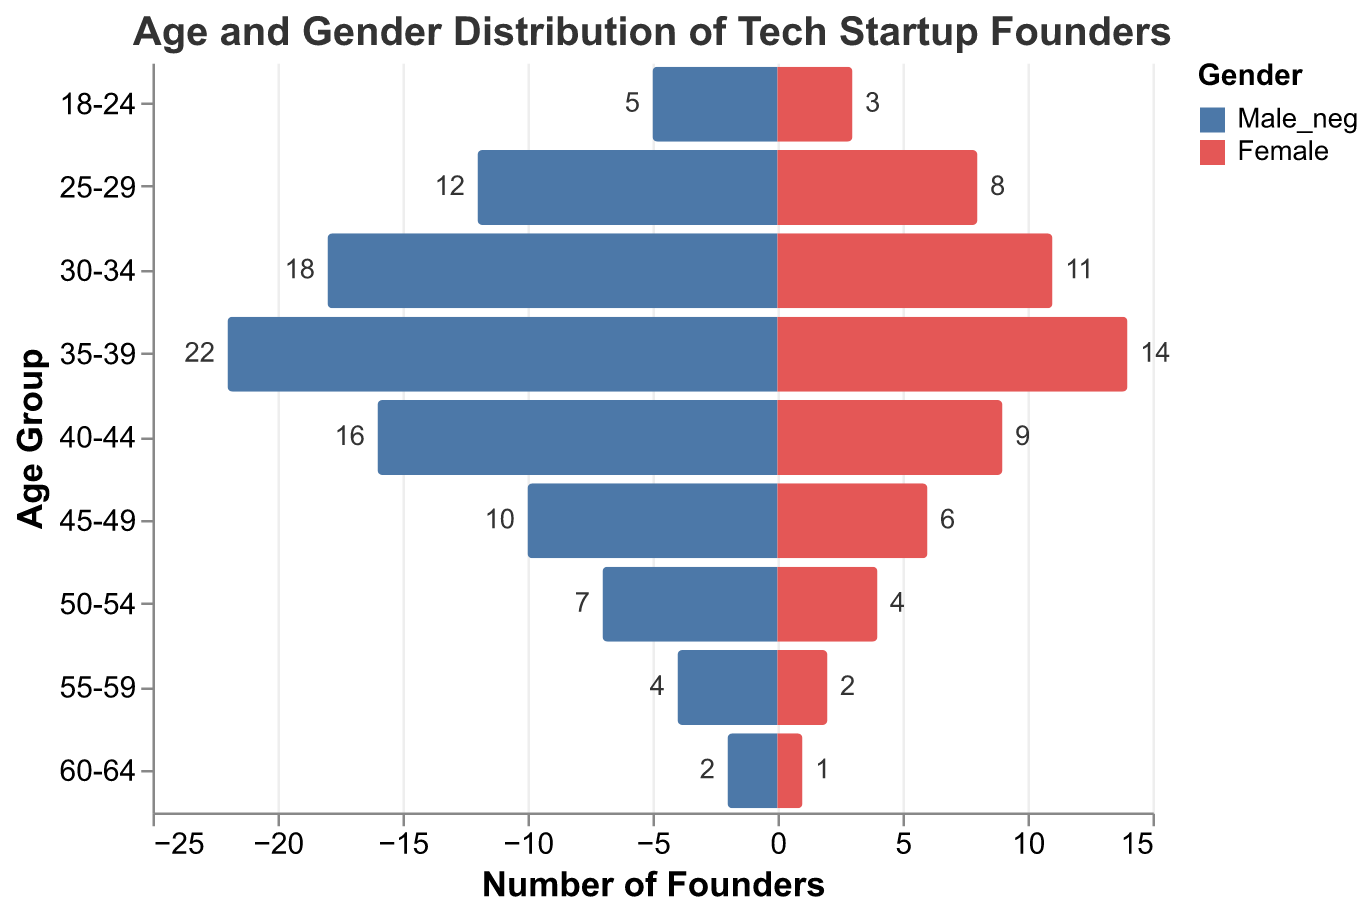What's the title of the figure? The title of the figure is placed at the top and clearly states the overall information the figure is presenting.
Answer: Age and Gender Distribution of Tech Startup Founders How many age groups are represented in the figure? Each age group is indicated on the vertical axis, and counting the number of different entries gives us the total number of groups.
Answer: 9 Which age group has the highest number of male startup founders? By observing the lengths of the bars representing male founders across different age groups, the longest bar indicates the highest number.
Answer: 35-39 How many more male founders are there in the 30-34 age group compared to female founders in the same group? The number of male founders in the 30-34 age group is shown as 18, and female founders as 11. The difference between the two gives the required value.
Answer: 7 What is the total number of female founders in the 40-44 and 45-49 age groups combined? Adding the number of female founders from the 40-44 age group (9) to the number of female founders from the 45-49 age group (6) gives the total.
Answer: 15 In which age group is the number of female founders highest, and what is that number? Observing the lengths of the bars representing female founders across different age groups, we find the longest bar indicates the highest number.
Answer: 35-39, 14 What is the combined total number of founders (both male and female) in the 25-29 age group? Adding the number of male founders (12) and female founders (8) in the 25-29 age group provides the total number.
Answer: 20 Is there an age group where the number of male founders is equal to the number of female founders? By comparing the lengths of the bars for male and female founders across all age groups, we confirm if any group's bars match in length.
Answer: No Which gender has more founders in the 55-59 age group, and by how many? Comparing the counts of male founders (4) and female founders (2) in the 55-59 age group, we determine the difference and the larger count.
Answer: Male, 2 What is the total number of male founders across all age groups? Adding up the number of male founders in each age group: 5 + 12 + 18 + 22 + 16 + 10 + 7 + 4 + 2, gives the total.
Answer: 96 